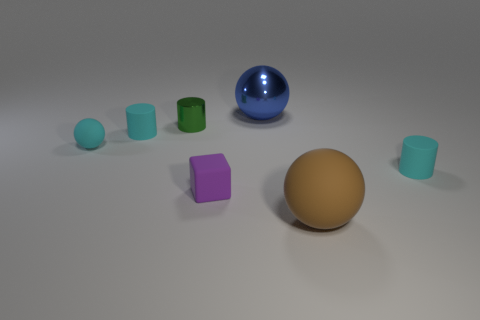Subtract all small rubber cylinders. How many cylinders are left? 1 Add 1 metal balls. How many objects exist? 8 Subtract all brown spheres. How many spheres are left? 2 Subtract all cubes. How many objects are left? 6 Subtract 3 spheres. How many spheres are left? 0 Subtract all green cubes. Subtract all brown spheres. How many cubes are left? 1 Subtract all green blocks. How many blue balls are left? 1 Subtract all big brown matte spheres. Subtract all large metallic things. How many objects are left? 5 Add 2 large matte spheres. How many large matte spheres are left? 3 Add 6 small cyan objects. How many small cyan objects exist? 9 